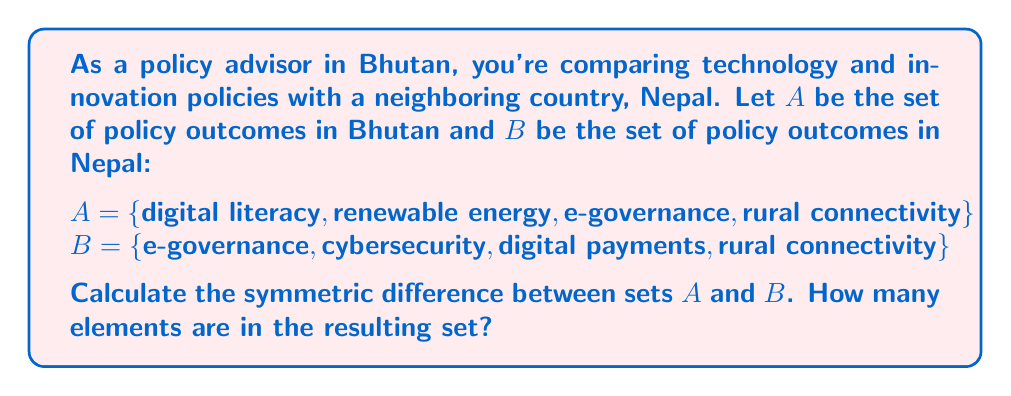Show me your answer to this math problem. To solve this problem, we need to understand the concept of symmetric difference and then apply it to the given sets.

1) The symmetric difference of two sets A and B, denoted by $A \triangle B$, is the set of elements that are in either A or B, but not in both.

2) Mathematically, this can be expressed as:
   $A \triangle B = (A \setminus B) \cup (B \setminus A)$

3) Let's identify the elements in each set:
   A = {digital literacy, renewable energy, e-governance, rural connectivity}
   B = {e-governance, cybersecurity, digital payments, rural connectivity}

4) Now, let's find $A \setminus B$ (elements in A but not in B):
   A \ B = {digital literacy, renewable energy}

5) Next, let's find $B \setminus A$ (elements in B but not in A):
   B \ A = {cybersecurity, digital payments}

6) The symmetric difference is the union of these two sets:
   $A \triangle B = \{digital literacy, renewable energy, cybersecurity, digital payments\}$

7) To count the elements in the resulting set, we simply need to count the unique elements:
   $|A \triangle B| = 4$

Therefore, the symmetric difference between the policy outcomes of Bhutan and Nepal contains 4 elements.
Answer: 4 